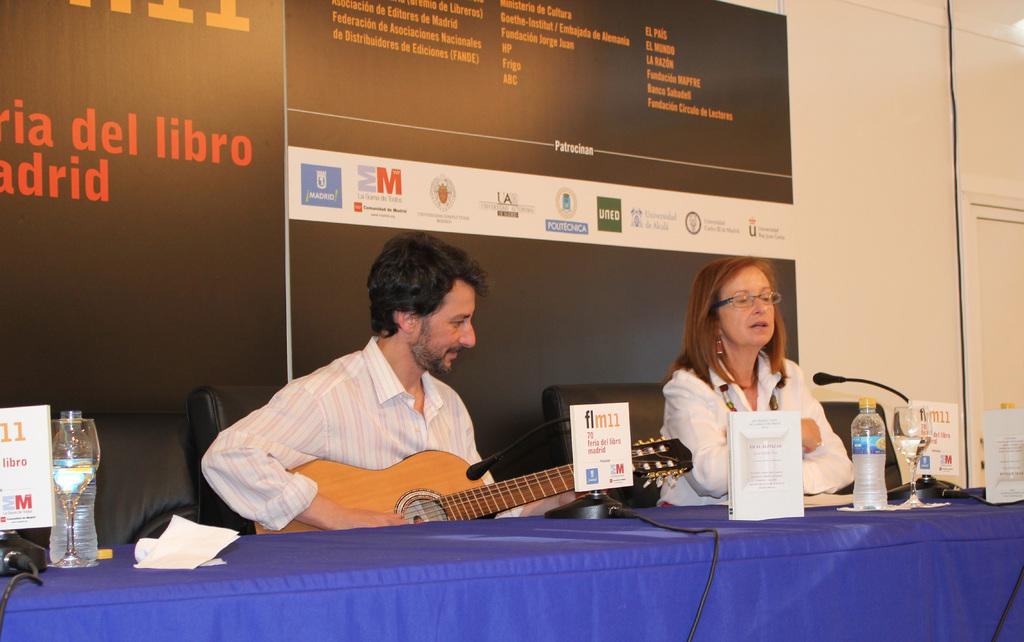Who are the people in the image? There is a man and a woman in the image. What are the man and woman doing in the image? The man and woman are sitting in the image. What is in front of the man and woman? There is a table in front of them. What can be seen on the table? There are water bottles on the table. What route are the man and woman discussing in the image? There is no indication in the image that the man and woman are discussing a route. 